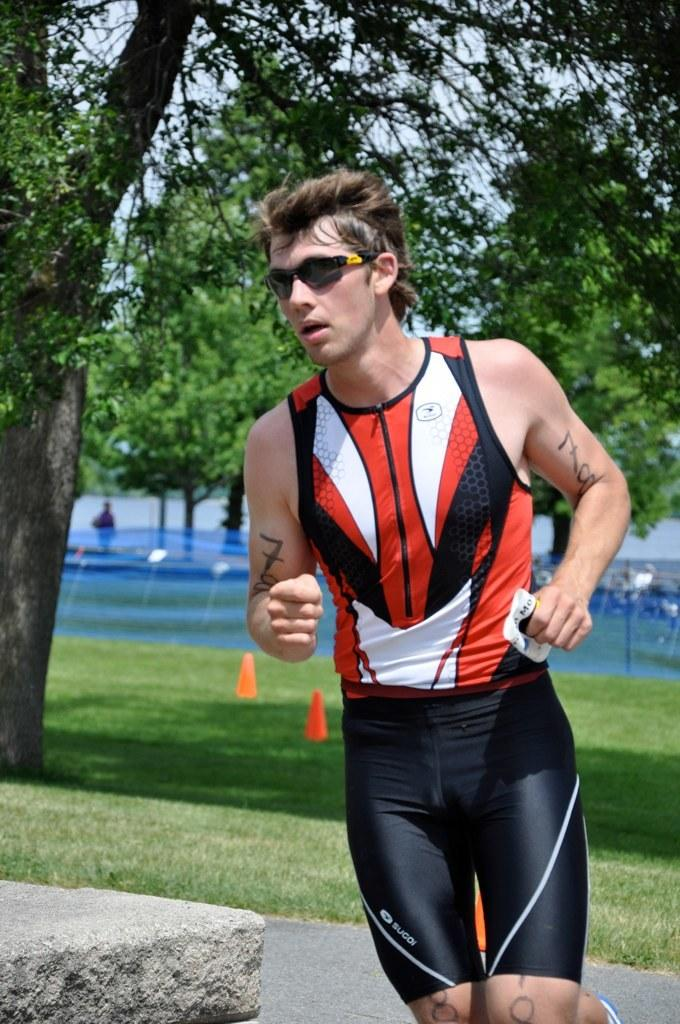Who is the main subject in the image? There is a man in the center of the image. What is the man doing in the image? The man appears to be running. What can be seen in the background of the image? There are trees, grassland, and water visible in the background of the image. What type of cat can be seen smoking in the image? There is no cat or smoke present in the image. 